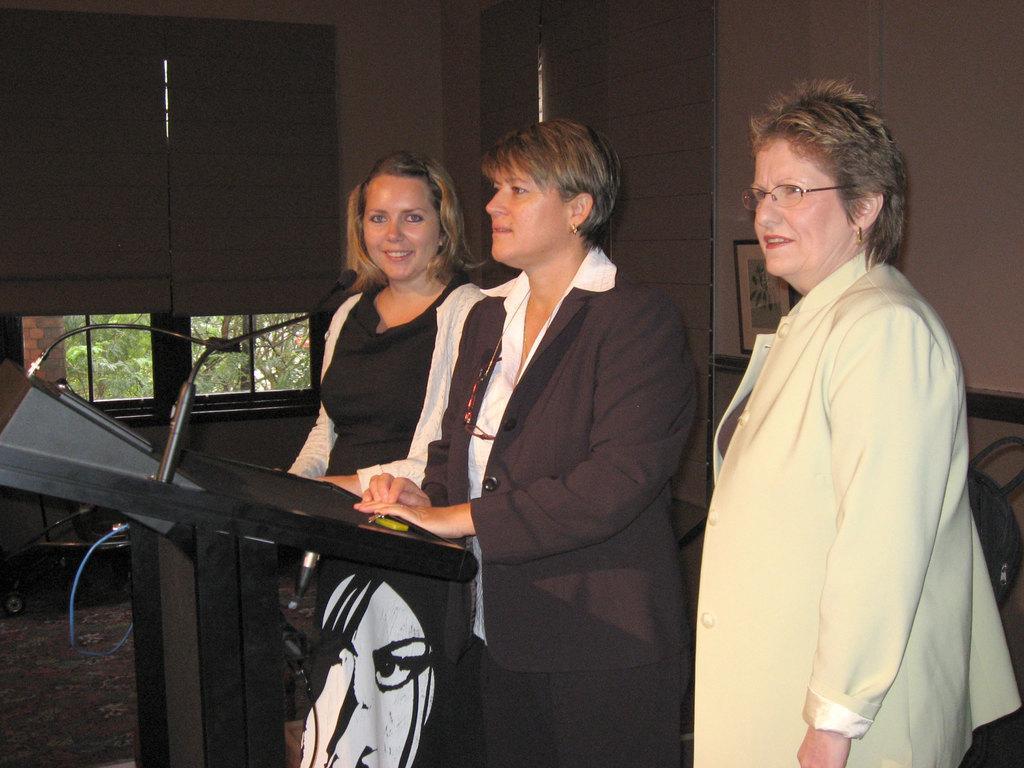Please provide a concise description of this image. In this picture we can see there are three people standing and in front of the people there is a podium and on the podium there are microphones. Behind the people there is a wall with a photo frame, a glass window and other things. Behind the window there are trees. 